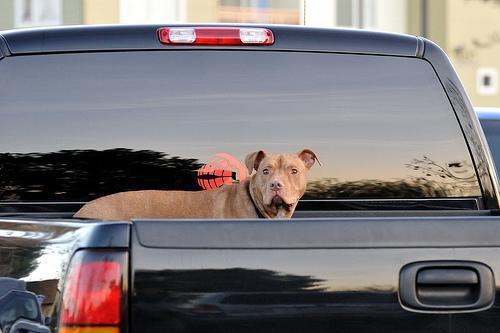How many colors are in the rear light at the top of the truck?
Give a very brief answer. 2. How many dogs are shown in the picture?
Give a very brief answer. 1. 